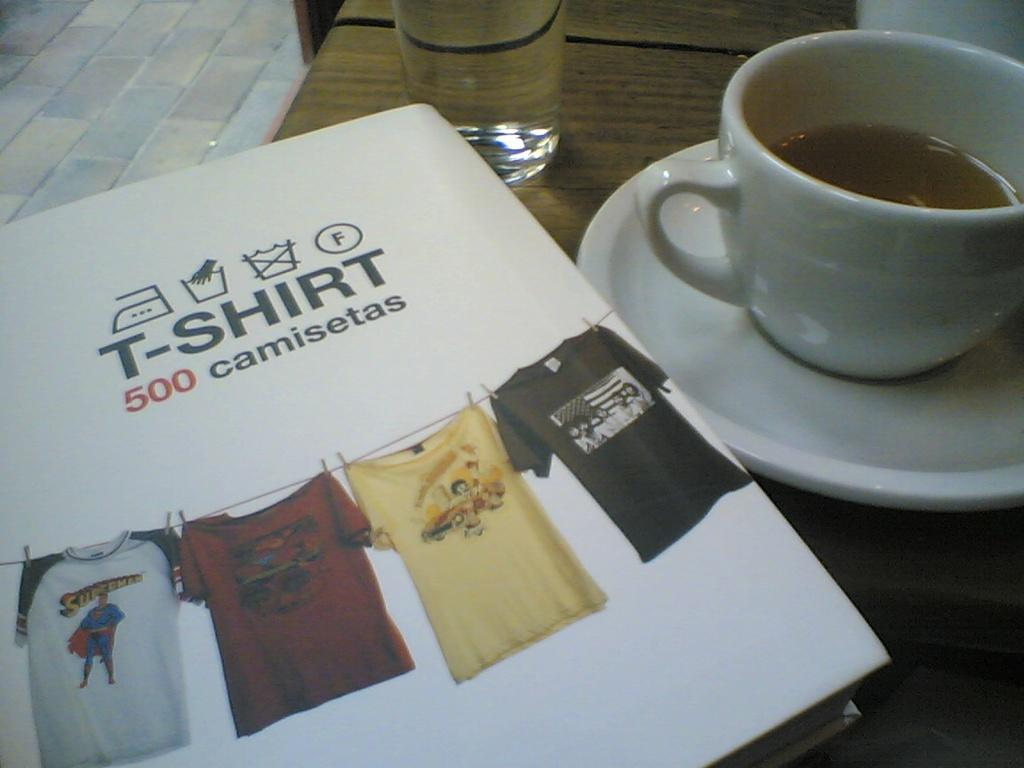<image>
Describe the image concisely. A book of T-Shirts sitting next to a cup of coffee on a saucer. 